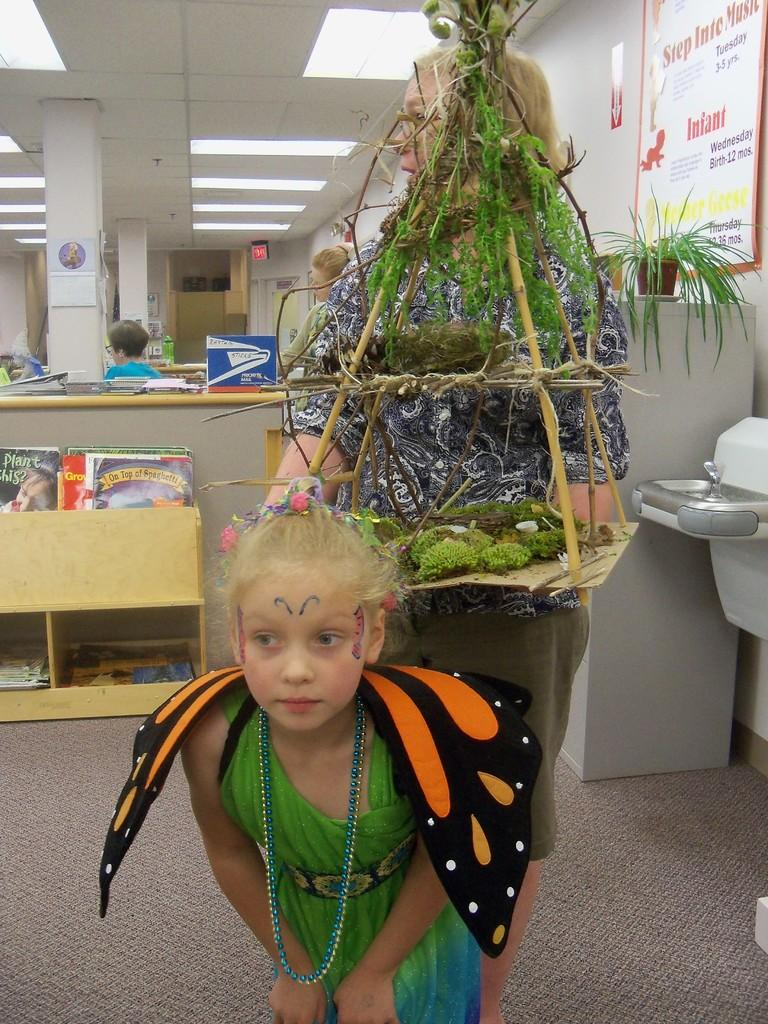Who is present in the image? There is a kid and a woman in the image. What is on the floor in the image? There is a carpet on the floor. What can be seen in the background of the image? There are plants, boards, books, pillars, lights, and a wall in the background of the image. How does the servant in the image help the woman? There is no servant present in the image. What type of nerve can be seen in the image? There is no nerve visible in the image. 